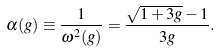Convert formula to latex. <formula><loc_0><loc_0><loc_500><loc_500>\alpha ( g ) \equiv \frac { 1 } { \omega ^ { 2 } ( g ) } = \frac { \sqrt { 1 + 3 g } - 1 } { 3 g } .</formula> 